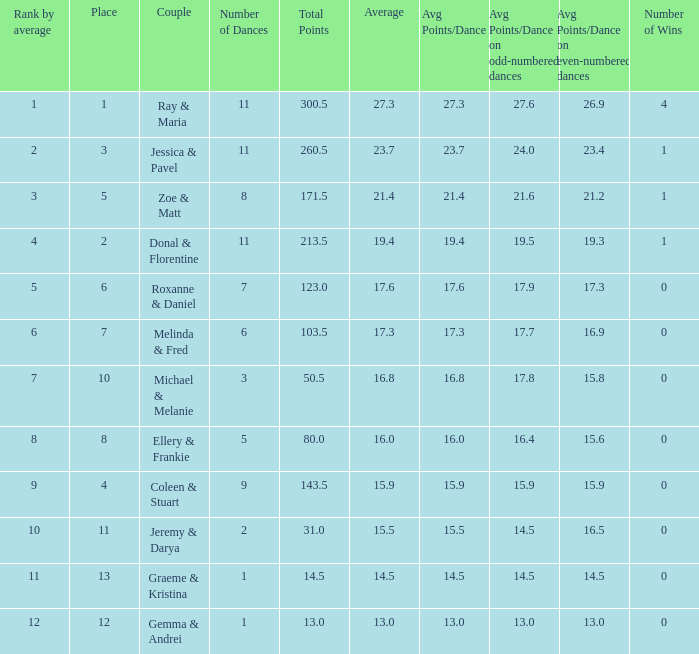What is the couples name where the average is 15.9? Coleen & Stuart. 